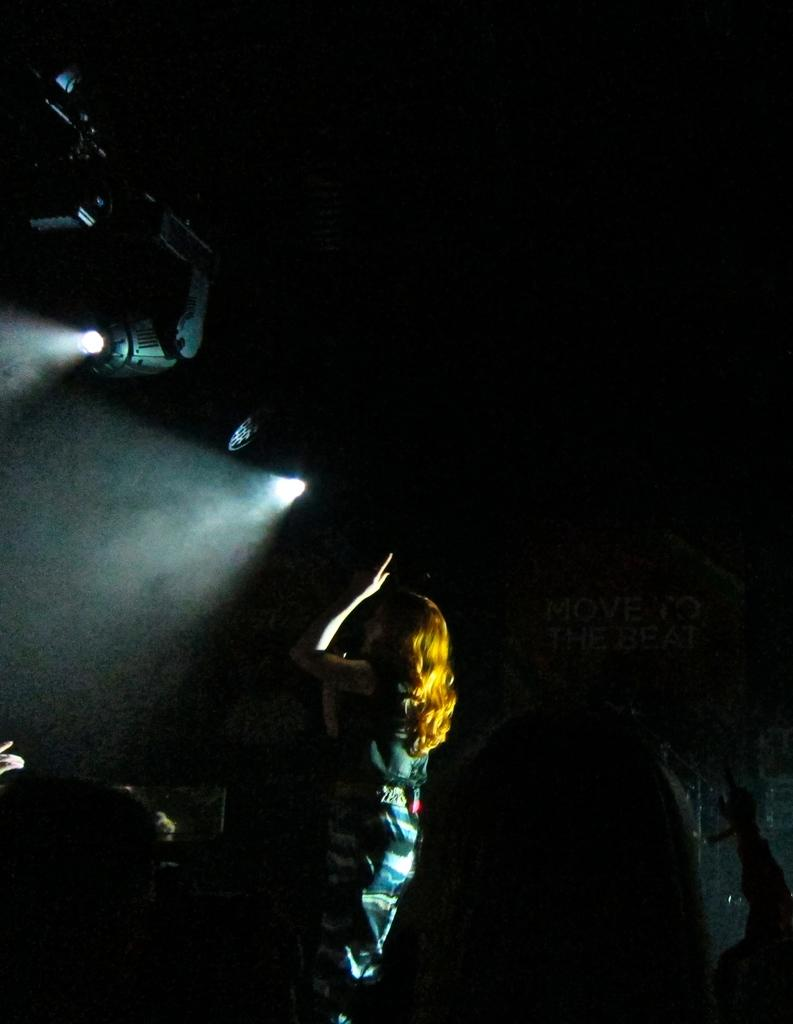What is the main subject in the image? There is a woman standing in the image. Are there any additional elements in the image besides the woman? Yes, there are focusing lights visible in the image. What type of umbrella is the woman holding in the image? There is no umbrella present in the image. What title does the woman have in the image? The image does not provide any information about the woman's title or role. 